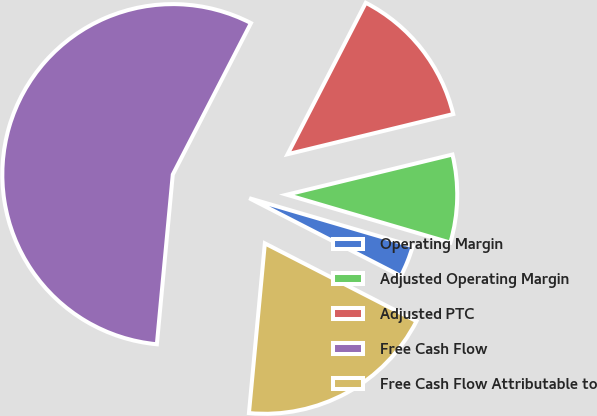<chart> <loc_0><loc_0><loc_500><loc_500><pie_chart><fcel>Operating Margin<fcel>Adjusted Operating Margin<fcel>Adjusted PTC<fcel>Free Cash Flow<fcel>Free Cash Flow Attributable to<nl><fcel>3.01%<fcel>8.32%<fcel>13.63%<fcel>56.09%<fcel>18.94%<nl></chart> 